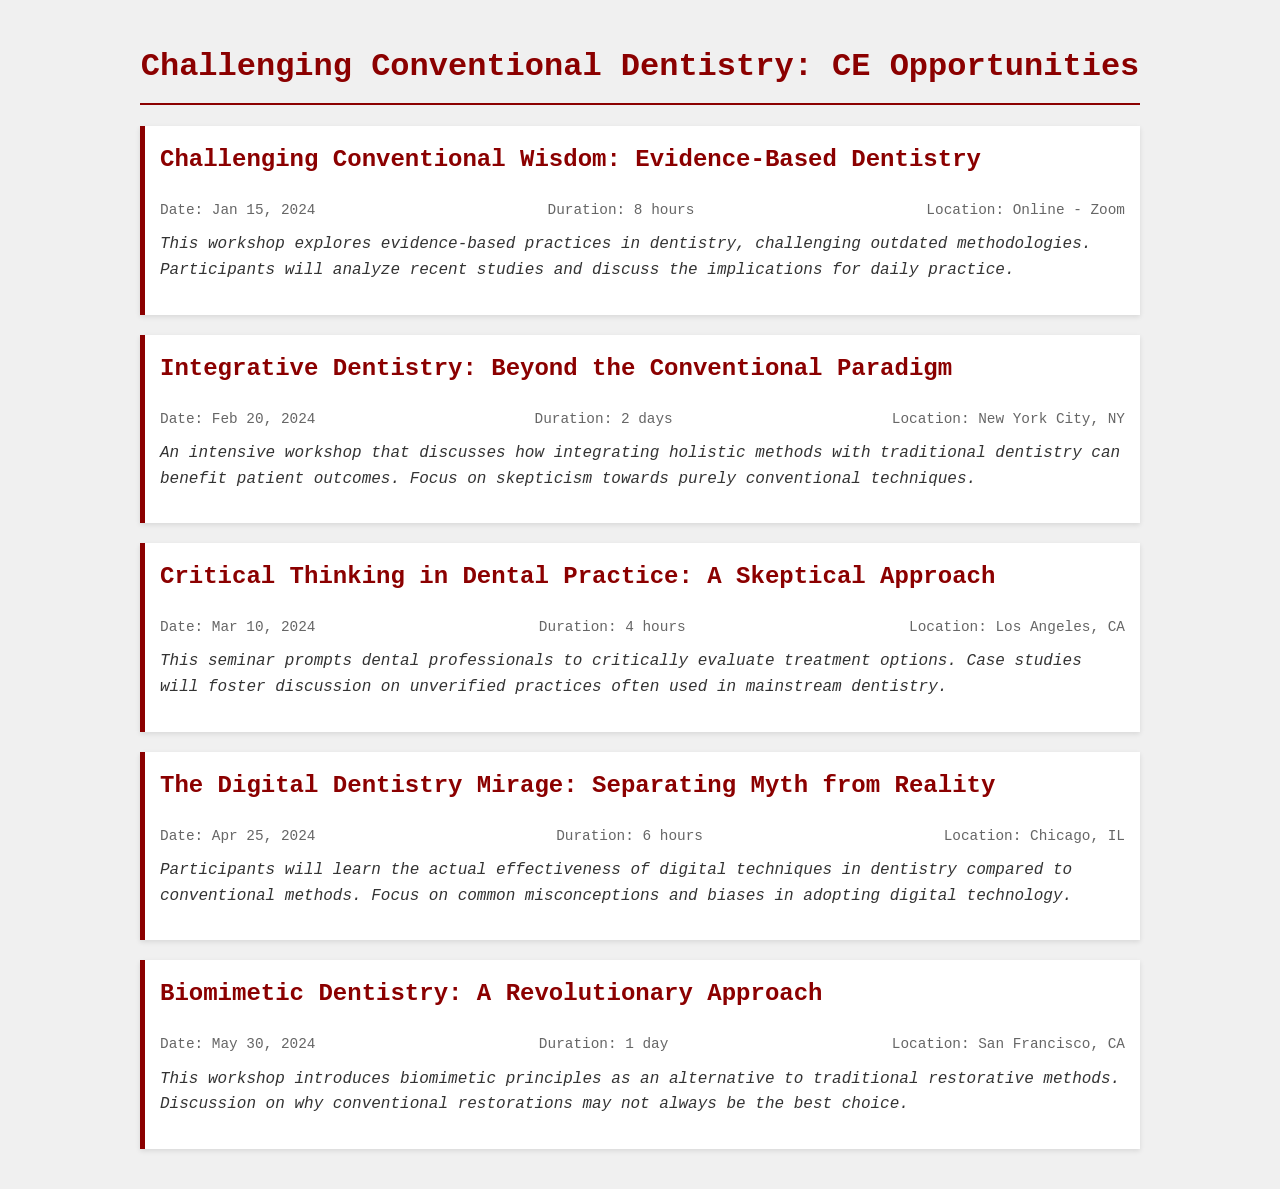What is the first workshop listed? The first workshop listed in the schedule is titled "Challenging Conventional Wisdom: Evidence-Based Dentistry."
Answer: Challenging Conventional Wisdom: Evidence-Based Dentistry When is the workshop on Integrative Dentistry? The workshop on Integrative Dentistry is scheduled for February 20, 2024.
Answer: February 20, 2024 How long is the seminar on Critical Thinking in Dental Practice? The seminar on Critical Thinking in Dental Practice has a duration of 4 hours.
Answer: 4 hours Where is the workshop on The Digital Dentistry Mirage held? The location for The Digital Dentistry Mirage workshop is Chicago, IL.
Answer: Chicago, IL What is the primary focus of the Biomimetic Dentistry workshop? The primary focus of the Biomimetic Dentistry workshop is to introduce biomimetic principles as an alternative to traditional restorative methods.
Answer: Introduce biomimetic principles What do participants evaluate in the Critical Thinking in Dental Practice seminar? Participants evaluate treatment options in the Critical Thinking in Dental Practice seminar.
Answer: Treatment options Which workshop emphasizes skepticism towards conventional techniques? The workshop that emphasizes skepticism towards conventional techniques is Integrative Dentistry: Beyond the Conventional Paradigm.
Answer: Integrative Dentistry: Beyond the Conventional Paradigm What is the duration of the workshop on Evidence-Based Dentistry? The workshop on Evidence-Based Dentistry lasts for 8 hours.
Answer: 8 hours 